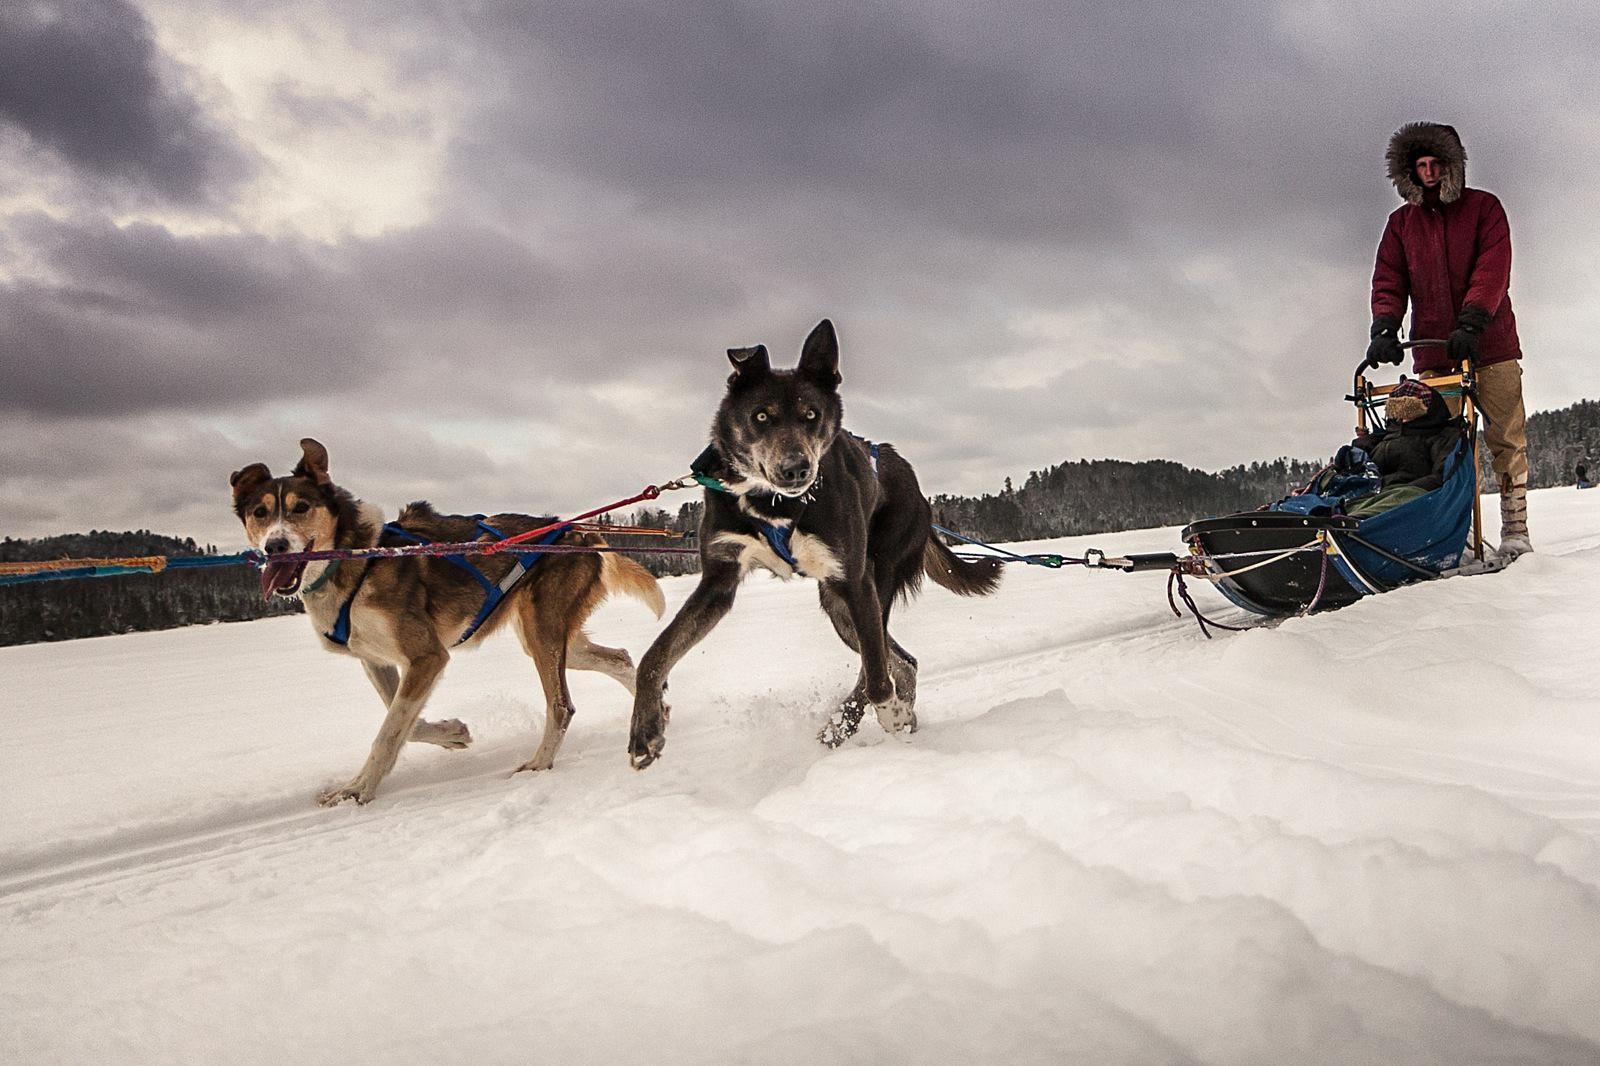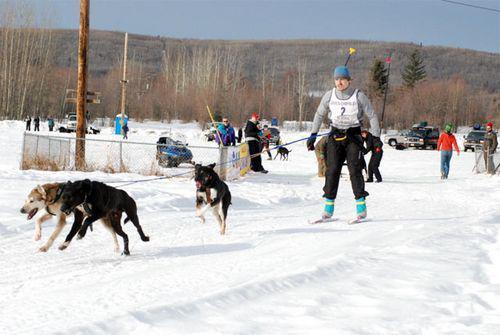The first image is the image on the left, the second image is the image on the right. Analyze the images presented: Is the assertion "Right image shows a team of harnessed dogs heading leftward, with a line of trees in the background." valid? Answer yes or no. Yes. The first image is the image on the left, the second image is the image on the right. Analyze the images presented: Is the assertion "The dogs are pulling a sled with a person wearing orange in one of the images." valid? Answer yes or no. No. 